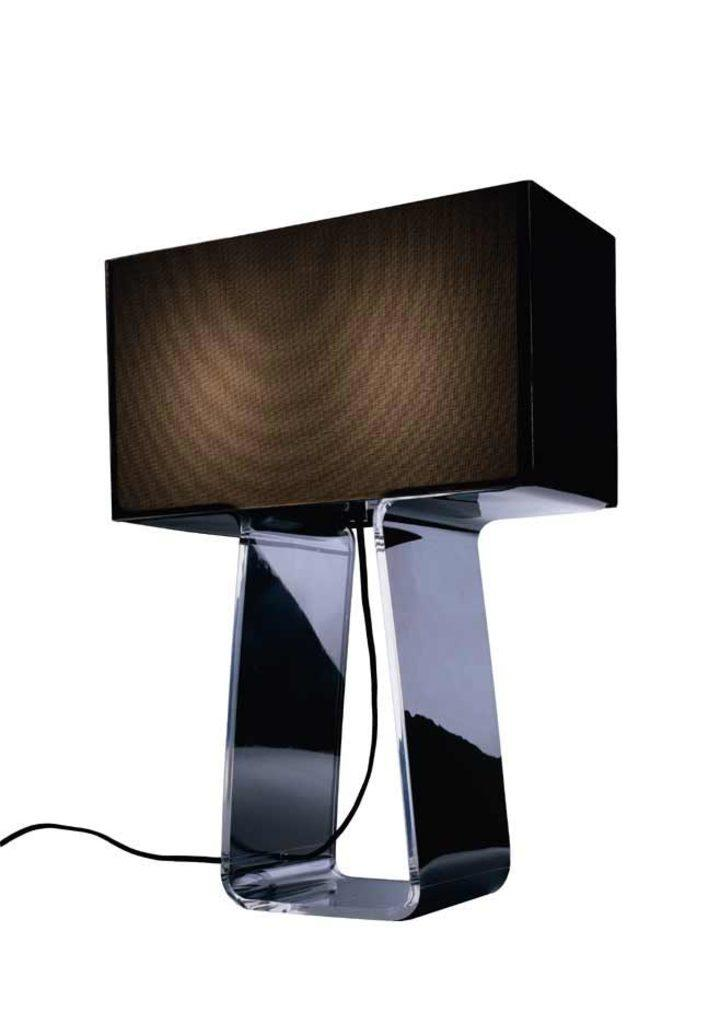What type of object with a stand is visible in the image? There is a metal object with a stand in the image. Is there any connection between the metal object and another object in the image? Yes, there is a wire connected to the metal object in the image. What type of grain is being processed by the metal object in the image? There is no grain or any indication of grain processing in the image; it only features a metal object with a stand and a wire connected to it. 